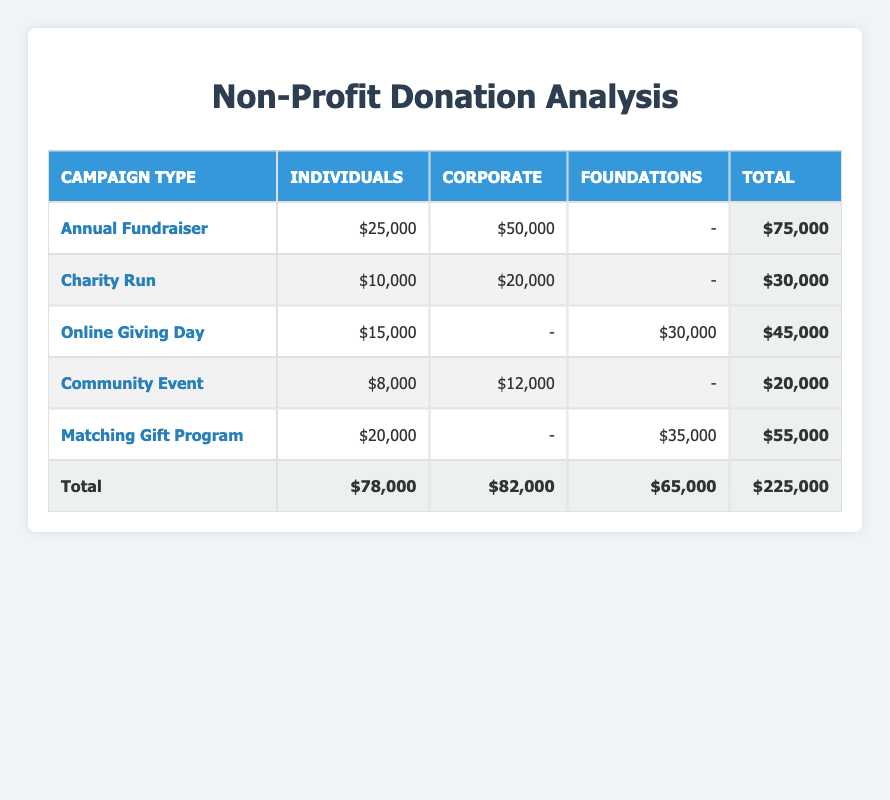What is the total amount raised from the Annual Fundraiser campaign? The total amount for the Annual Fundraiser is found in the row corresponding to this campaign; the total is shown in the last column as $75,000.
Answer: 75,000 Which donor demographic contributed the least across all campaigns? By looking at the individual values in the columns for each donor demographic and comparing them, I see that the total contribution by Individuals is $78,000, Corporates is $82,000, and Foundations is $65,000. Foundations contributed the least.
Answer: Foundations Is there a campaign where Corporate donations contributed more than Individuals? In the Annual Fundraiser and Charity Run campaigns, Corporate donations ($50,000 and $20,000 respectively) exceed Individual donations ($25,000 and $10,000). The total in the Community Event campaign also shows this trend.
Answer: Yes What is the total amount donated by each donor demographic? To find the total for each demographic, I sum the column values: Individuals ($78,000), Corporate ($82,000), and Foundations ($65,000). The totals are listed in the last row of the table.
Answer: Individuals: 78,000, Corporate: 82,000, Foundations: 65,000 How much did Foundations donate in total, and how does that compare to Corporate donations? Foundations contributed $65,000 as depicted in the last row of the table, while Corporate donations totaled $82,000. By comparing these values, Corporate donations are higher.
Answer: Corporate donations are higher What is the average contribution of Individuals in the campaigns? To calculate the average for Individuals, add their contributions: $25,000 + $10,000 + $15,000 + $8,000 + $20,000 = $78,000. There are 5 contributions, so the average is $78,000 divided by 5, equaling $15,600.
Answer: 15,600 Which campaign received no contributions from Corporates? By inspecting the table, Online Giving Day and Matching Gift Program show a dash (-) under Corporate donations, indicating no contributions.
Answer: Online Giving Day and Matching Gift Program Is the total amount from Matching Gift Program higher than that from Charity Run? The total from Matching Gift Program is $55,000 while the total from Charity Run is $30,000. Since $55,000 is greater than $30,000, the Matching Gift Program has received a higher total amount.
Answer: Yes 